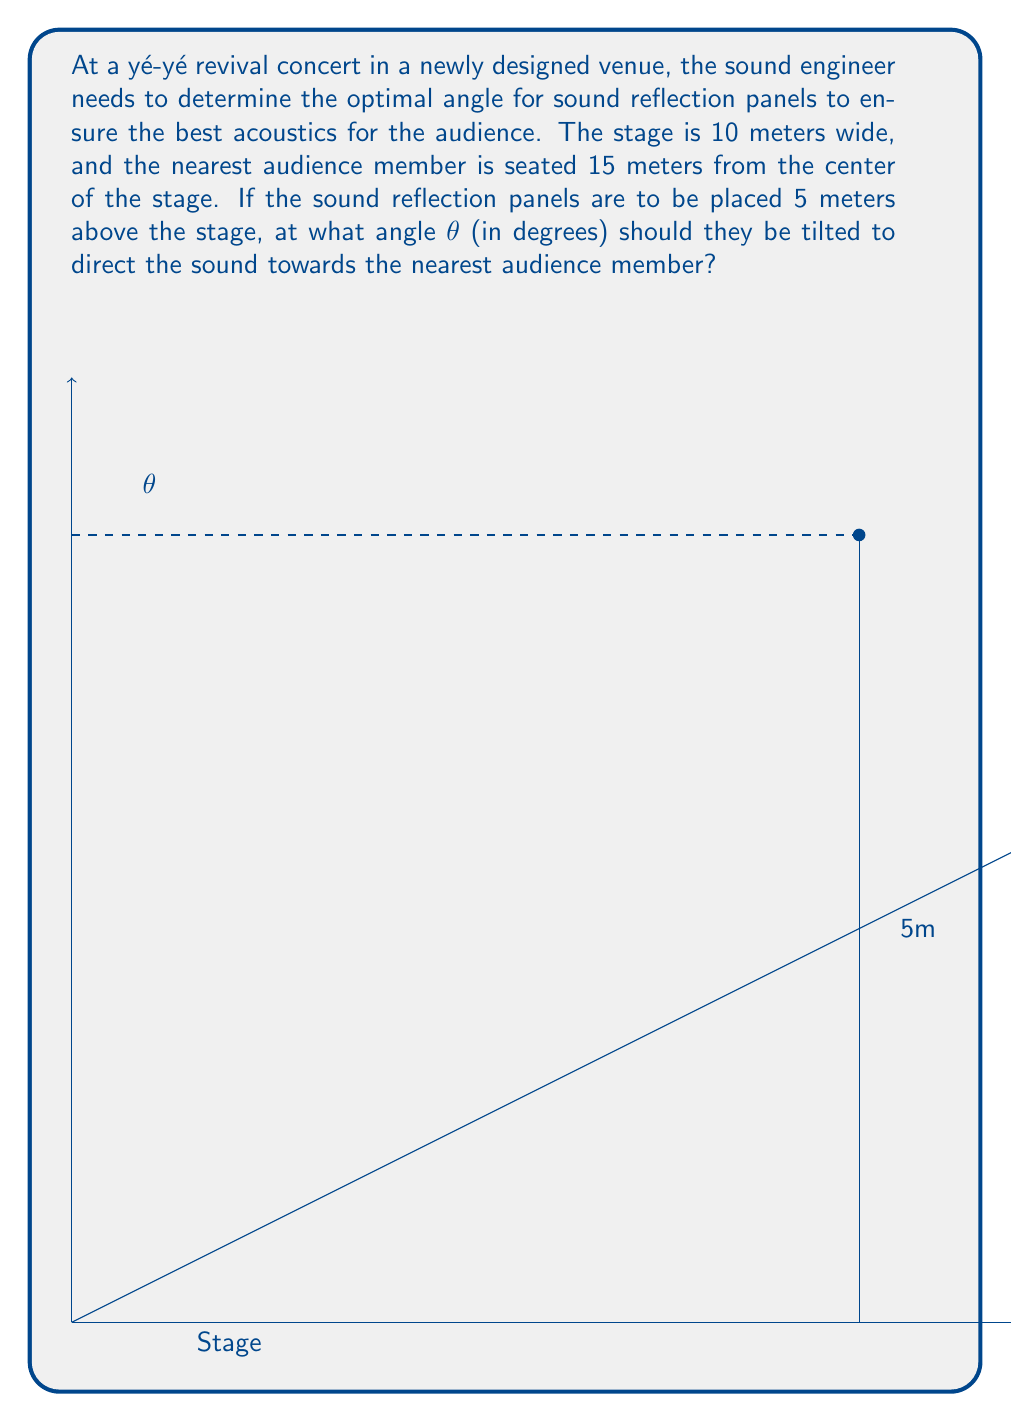Could you help me with this problem? To solve this problem, we'll use trigonometry and the properties of similar triangles. Let's break it down step by step:

1) First, we need to identify the right triangle formed by the sound reflection panel, the vertical line above the stage edge, and the line to the audience member.

2) We know two sides of this triangle:
   - The vertical height of the panel: 5 meters
   - The horizontal distance to the audience: 15 meters

3) We can use the tangent function to find the angle θ:

   $$\tan(\theta) = \frac{\text{opposite}}{\text{adjacent}} = \frac{5}{15}$$

4) To solve for θ, we need to use the inverse tangent (arctangent) function:

   $$\theta = \arctan(\frac{5}{15})$$

5) Using a calculator or computer:

   $$\theta = \arctan(0.3333...) \approx 18.43494882292201^\circ$$

6) Rounding to two decimal places for practical use:

   $$\theta \approx 18.43^\circ$$

This angle will ensure that the sound from the center of the stage is reflected directly towards the nearest audience member, optimizing the acoustics for the yé-yé revival concert.
Answer: The optimal angle for the sound reflection panels is approximately 18.43°. 